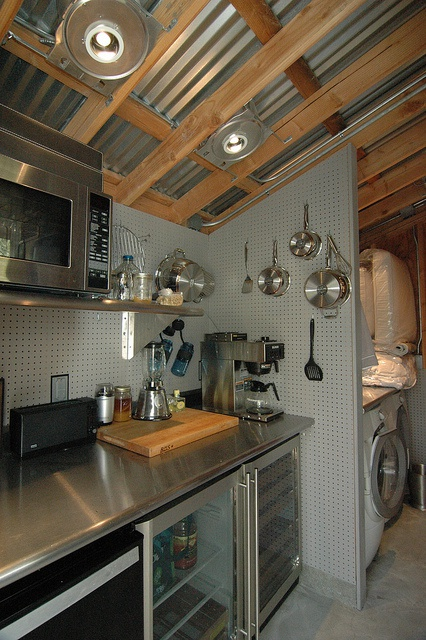Describe the objects in this image and their specific colors. I can see refrigerator in maroon, gray, black, and darkgray tones, microwave in maroon, black, and gray tones, oven in maroon, black, and gray tones, bottle in maroon, black, darkgreen, and gray tones, and bottle in maroon, black, teal, darkblue, and gray tones in this image. 